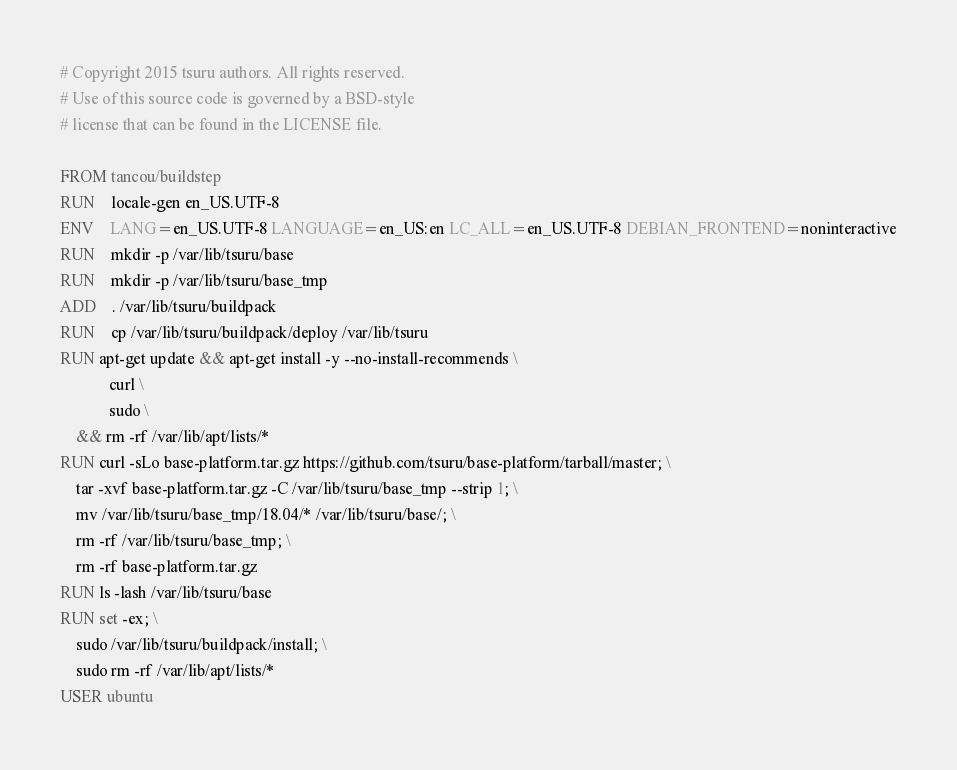<code> <loc_0><loc_0><loc_500><loc_500><_Dockerfile_># Copyright 2015 tsuru authors. All rights reserved.
# Use of this source code is governed by a BSD-style
# license that can be found in the LICENSE file.

FROM tancou/buildstep
RUN	locale-gen en_US.UTF-8
ENV	LANG=en_US.UTF-8 LANGUAGE=en_US:en LC_ALL=en_US.UTF-8 DEBIAN_FRONTEND=noninteractive
RUN	mkdir -p /var/lib/tsuru/base
RUN	mkdir -p /var/lib/tsuru/base_tmp
ADD	. /var/lib/tsuru/buildpack
RUN	cp /var/lib/tsuru/buildpack/deploy /var/lib/tsuru
RUN apt-get update && apt-get install -y --no-install-recommends \
            curl \
            sudo \
    && rm -rf /var/lib/apt/lists/*
RUN curl -sLo base-platform.tar.gz https://github.com/tsuru/base-platform/tarball/master; \
    tar -xvf base-platform.tar.gz -C /var/lib/tsuru/base_tmp --strip 1; \
    mv /var/lib/tsuru/base_tmp/18.04/* /var/lib/tsuru/base/; \
    rm -rf /var/lib/tsuru/base_tmp; \
    rm -rf base-platform.tar.gz
RUN ls -lash /var/lib/tsuru/base
RUN set -ex; \
    sudo /var/lib/tsuru/buildpack/install; \
    sudo rm -rf /var/lib/apt/lists/*
USER ubuntu
</code> 